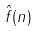<formula> <loc_0><loc_0><loc_500><loc_500>\hat { f } ( n )</formula> 